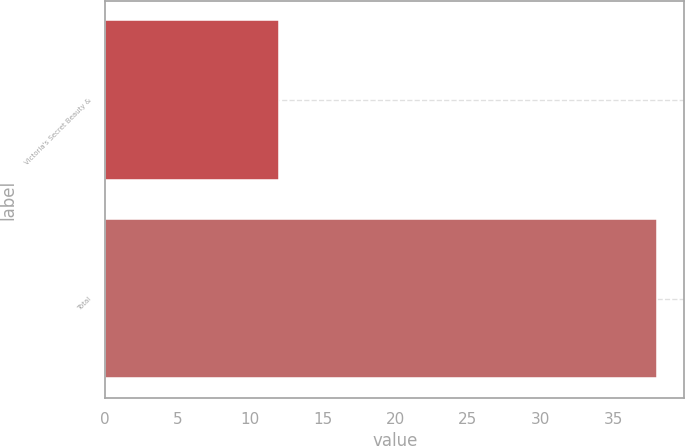Convert chart to OTSL. <chart><loc_0><loc_0><loc_500><loc_500><bar_chart><fcel>Victoria's Secret Beauty &<fcel>Total<nl><fcel>12<fcel>38<nl></chart> 